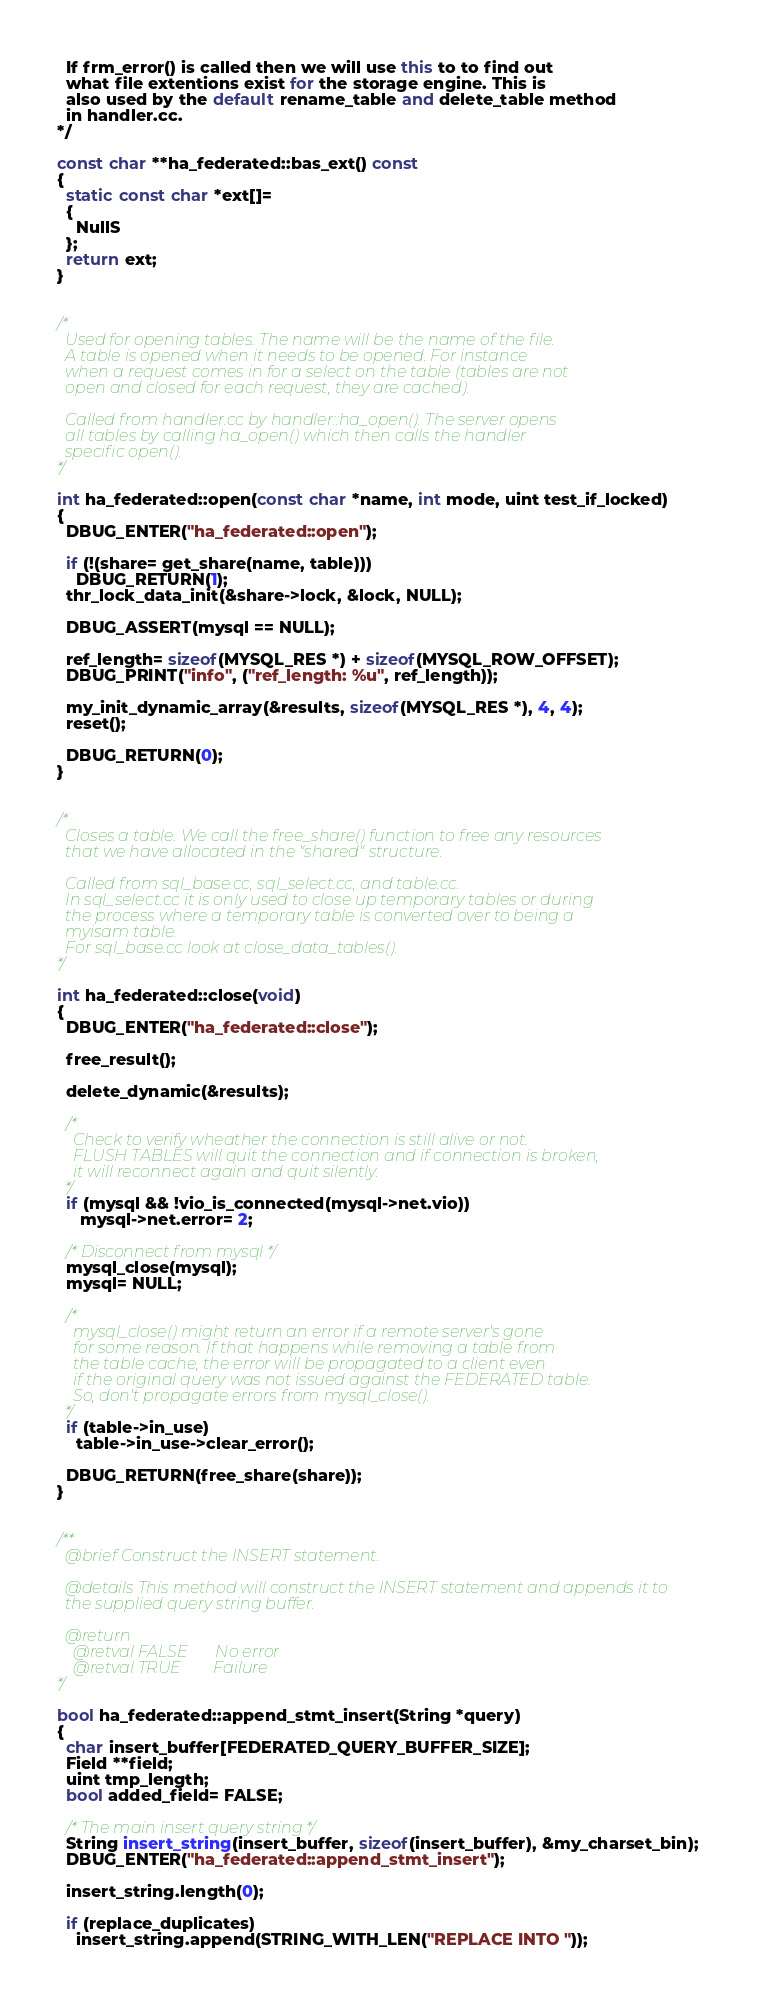<code> <loc_0><loc_0><loc_500><loc_500><_C++_>  If frm_error() is called then we will use this to to find out
  what file extentions exist for the storage engine. This is
  also used by the default rename_table and delete_table method
  in handler.cc.
*/

const char **ha_federated::bas_ext() const
{
  static const char *ext[]=
  {
    NullS
  };
  return ext;
}


/*
  Used for opening tables. The name will be the name of the file.
  A table is opened when it needs to be opened. For instance
  when a request comes in for a select on the table (tables are not
  open and closed for each request, they are cached).

  Called from handler.cc by handler::ha_open(). The server opens
  all tables by calling ha_open() which then calls the handler
  specific open().
*/

int ha_federated::open(const char *name, int mode, uint test_if_locked)
{
  DBUG_ENTER("ha_federated::open");

  if (!(share= get_share(name, table)))
    DBUG_RETURN(1);
  thr_lock_data_init(&share->lock, &lock, NULL);

  DBUG_ASSERT(mysql == NULL);

  ref_length= sizeof(MYSQL_RES *) + sizeof(MYSQL_ROW_OFFSET);
  DBUG_PRINT("info", ("ref_length: %u", ref_length));

  my_init_dynamic_array(&results, sizeof(MYSQL_RES *), 4, 4);
  reset();

  DBUG_RETURN(0);
}


/*
  Closes a table. We call the free_share() function to free any resources
  that we have allocated in the "shared" structure.

  Called from sql_base.cc, sql_select.cc, and table.cc.
  In sql_select.cc it is only used to close up temporary tables or during
  the process where a temporary table is converted over to being a
  myisam table.
  For sql_base.cc look at close_data_tables().
*/

int ha_federated::close(void)
{
  DBUG_ENTER("ha_federated::close");

  free_result();

  delete_dynamic(&results);

  /*
    Check to verify wheather the connection is still alive or not.
    FLUSH TABLES will quit the connection and if connection is broken,
    it will reconnect again and quit silently.
  */
  if (mysql && !vio_is_connected(mysql->net.vio))
     mysql->net.error= 2;

  /* Disconnect from mysql */
  mysql_close(mysql);
  mysql= NULL;

  /*
    mysql_close() might return an error if a remote server's gone
    for some reason. If that happens while removing a table from
    the table cache, the error will be propagated to a client even
    if the original query was not issued against the FEDERATED table.
    So, don't propagate errors from mysql_close().
  */
  if (table->in_use)
    table->in_use->clear_error();

  DBUG_RETURN(free_share(share));
}


/**
  @brief Construct the INSERT statement.
  
  @details This method will construct the INSERT statement and appends it to
  the supplied query string buffer.
  
  @return
    @retval FALSE       No error
    @retval TRUE        Failure
*/

bool ha_federated::append_stmt_insert(String *query)
{
  char insert_buffer[FEDERATED_QUERY_BUFFER_SIZE];
  Field **field;
  uint tmp_length;
  bool added_field= FALSE;

  /* The main insert query string */
  String insert_string(insert_buffer, sizeof(insert_buffer), &my_charset_bin);
  DBUG_ENTER("ha_federated::append_stmt_insert");

  insert_string.length(0);

  if (replace_duplicates)
    insert_string.append(STRING_WITH_LEN("REPLACE INTO "));</code> 